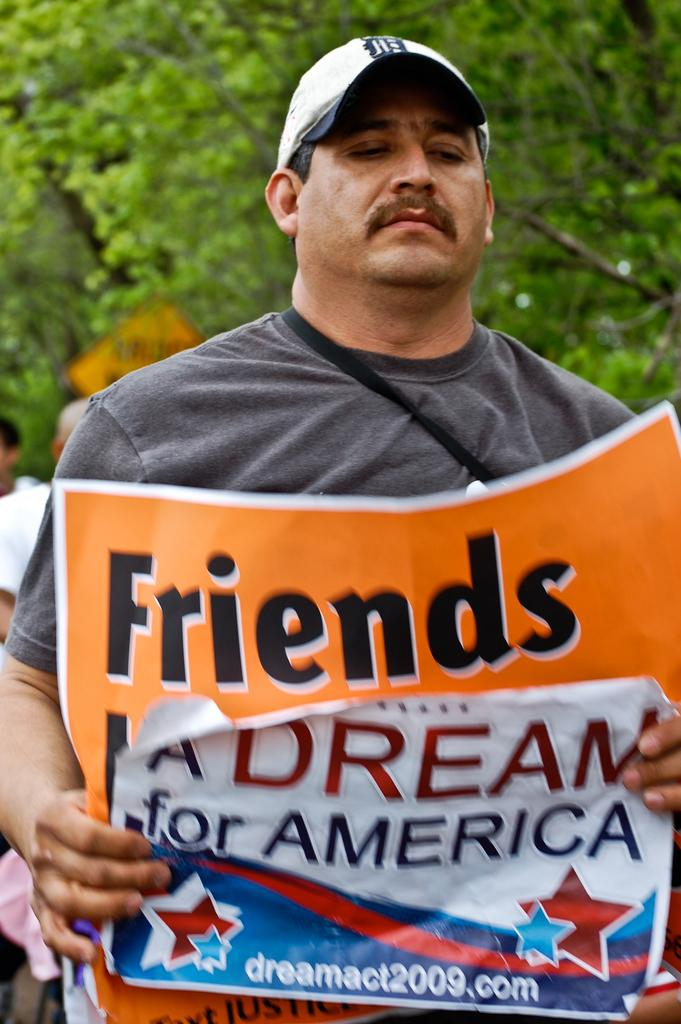<image>
Write a terse but informative summary of the picture. A guy holding a sign that says A Dream for America. 